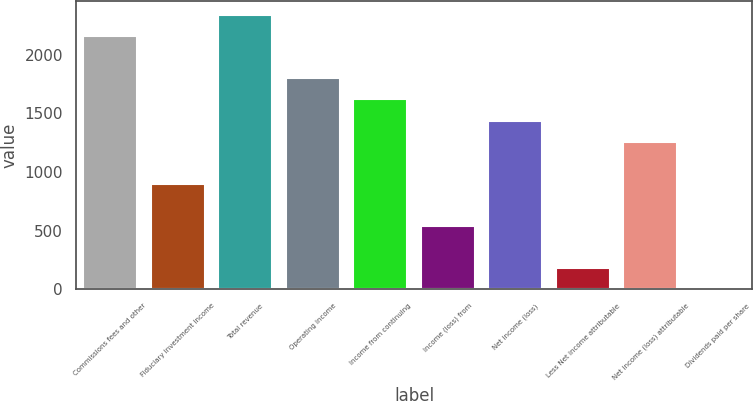Convert chart. <chart><loc_0><loc_0><loc_500><loc_500><bar_chart><fcel>Commissions fees and other<fcel>Fiduciary investment income<fcel>Total revenue<fcel>Operating income<fcel>Income from continuing<fcel>Income (loss) from<fcel>Net income (loss)<fcel>Less Net income attributable<fcel>Net income (loss) attributable<fcel>Dividends paid per share<nl><fcel>2157.59<fcel>899.07<fcel>2337.38<fcel>1798.01<fcel>1618.22<fcel>539.51<fcel>1438.43<fcel>179.94<fcel>1258.64<fcel>0.15<nl></chart> 